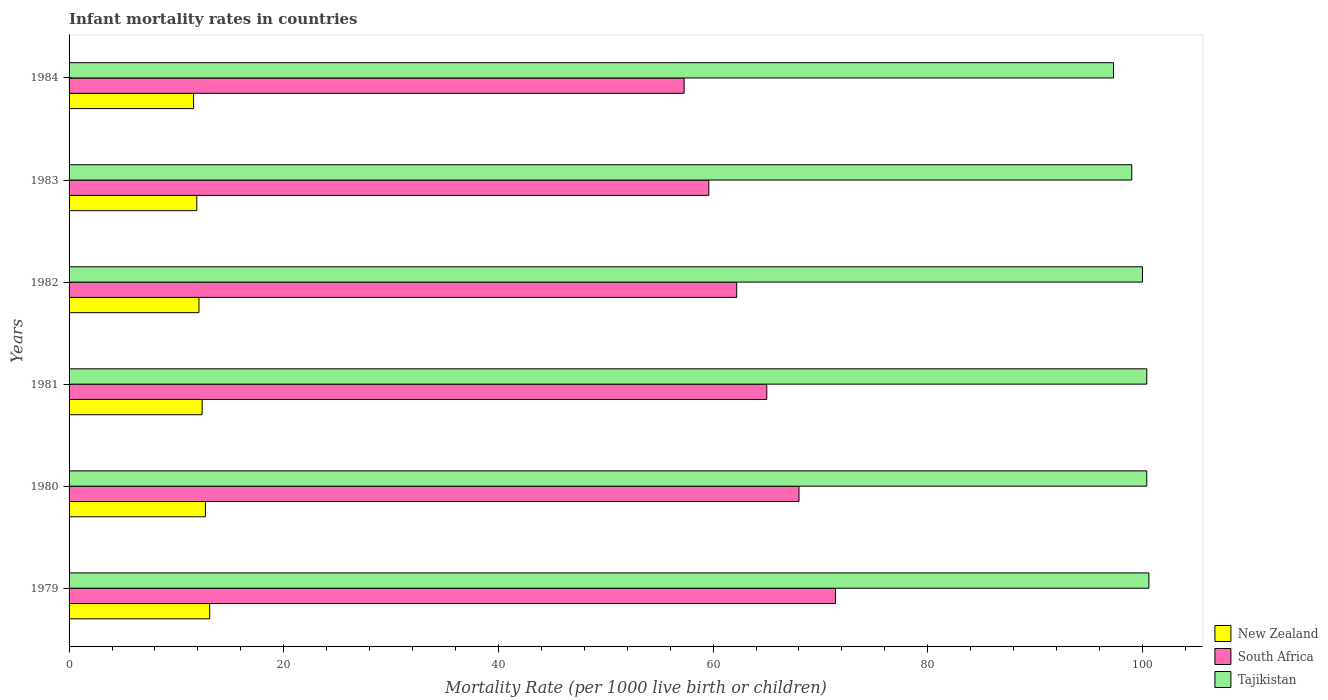How many groups of bars are there?
Your answer should be very brief. 6. How many bars are there on the 3rd tick from the bottom?
Ensure brevity in your answer.  3. What is the label of the 6th group of bars from the top?
Your answer should be compact. 1979. In how many cases, is the number of bars for a given year not equal to the number of legend labels?
Provide a short and direct response. 0. What is the infant mortality rate in Tajikistan in 1982?
Your answer should be compact. 100. Across all years, what is the minimum infant mortality rate in South Africa?
Offer a terse response. 57.3. In which year was the infant mortality rate in South Africa maximum?
Your answer should be very brief. 1979. What is the total infant mortality rate in South Africa in the graph?
Offer a very short reply. 383.5. What is the difference between the infant mortality rate in New Zealand in 1982 and that in 1984?
Give a very brief answer. 0.5. What is the average infant mortality rate in New Zealand per year?
Your answer should be compact. 12.3. In the year 1983, what is the difference between the infant mortality rate in Tajikistan and infant mortality rate in South Africa?
Provide a succinct answer. 39.4. In how many years, is the infant mortality rate in Tajikistan greater than 84 ?
Provide a short and direct response. 6. What is the ratio of the infant mortality rate in Tajikistan in 1979 to that in 1983?
Your answer should be compact. 1.02. What is the difference between the highest and the second highest infant mortality rate in South Africa?
Your answer should be very brief. 3.4. What is the difference between the highest and the lowest infant mortality rate in South Africa?
Keep it short and to the point. 14.1. What does the 2nd bar from the top in 1981 represents?
Give a very brief answer. South Africa. What does the 2nd bar from the bottom in 1983 represents?
Offer a very short reply. South Africa. Is it the case that in every year, the sum of the infant mortality rate in Tajikistan and infant mortality rate in South Africa is greater than the infant mortality rate in New Zealand?
Keep it short and to the point. Yes. How many bars are there?
Keep it short and to the point. 18. Are the values on the major ticks of X-axis written in scientific E-notation?
Your response must be concise. No. How are the legend labels stacked?
Offer a terse response. Vertical. What is the title of the graph?
Keep it short and to the point. Infant mortality rates in countries. What is the label or title of the X-axis?
Give a very brief answer. Mortality Rate (per 1000 live birth or children). What is the label or title of the Y-axis?
Your answer should be very brief. Years. What is the Mortality Rate (per 1000 live birth or children) of South Africa in 1979?
Offer a terse response. 71.4. What is the Mortality Rate (per 1000 live birth or children) of Tajikistan in 1979?
Offer a terse response. 100.6. What is the Mortality Rate (per 1000 live birth or children) of New Zealand in 1980?
Ensure brevity in your answer.  12.7. What is the Mortality Rate (per 1000 live birth or children) in South Africa in 1980?
Keep it short and to the point. 68. What is the Mortality Rate (per 1000 live birth or children) in Tajikistan in 1980?
Ensure brevity in your answer.  100.4. What is the Mortality Rate (per 1000 live birth or children) of New Zealand in 1981?
Give a very brief answer. 12.4. What is the Mortality Rate (per 1000 live birth or children) in Tajikistan in 1981?
Keep it short and to the point. 100.4. What is the Mortality Rate (per 1000 live birth or children) of New Zealand in 1982?
Keep it short and to the point. 12.1. What is the Mortality Rate (per 1000 live birth or children) of South Africa in 1982?
Make the answer very short. 62.2. What is the Mortality Rate (per 1000 live birth or children) in Tajikistan in 1982?
Offer a very short reply. 100. What is the Mortality Rate (per 1000 live birth or children) in New Zealand in 1983?
Your response must be concise. 11.9. What is the Mortality Rate (per 1000 live birth or children) in South Africa in 1983?
Make the answer very short. 59.6. What is the Mortality Rate (per 1000 live birth or children) of Tajikistan in 1983?
Your answer should be very brief. 99. What is the Mortality Rate (per 1000 live birth or children) in New Zealand in 1984?
Your answer should be very brief. 11.6. What is the Mortality Rate (per 1000 live birth or children) in South Africa in 1984?
Give a very brief answer. 57.3. What is the Mortality Rate (per 1000 live birth or children) in Tajikistan in 1984?
Provide a short and direct response. 97.3. Across all years, what is the maximum Mortality Rate (per 1000 live birth or children) in South Africa?
Offer a very short reply. 71.4. Across all years, what is the maximum Mortality Rate (per 1000 live birth or children) of Tajikistan?
Offer a very short reply. 100.6. Across all years, what is the minimum Mortality Rate (per 1000 live birth or children) in South Africa?
Provide a succinct answer. 57.3. Across all years, what is the minimum Mortality Rate (per 1000 live birth or children) of Tajikistan?
Keep it short and to the point. 97.3. What is the total Mortality Rate (per 1000 live birth or children) in New Zealand in the graph?
Offer a terse response. 73.8. What is the total Mortality Rate (per 1000 live birth or children) of South Africa in the graph?
Your answer should be compact. 383.5. What is the total Mortality Rate (per 1000 live birth or children) of Tajikistan in the graph?
Offer a terse response. 597.7. What is the difference between the Mortality Rate (per 1000 live birth or children) of New Zealand in 1979 and that in 1980?
Your response must be concise. 0.4. What is the difference between the Mortality Rate (per 1000 live birth or children) in New Zealand in 1979 and that in 1981?
Offer a very short reply. 0.7. What is the difference between the Mortality Rate (per 1000 live birth or children) in Tajikistan in 1979 and that in 1981?
Make the answer very short. 0.2. What is the difference between the Mortality Rate (per 1000 live birth or children) in South Africa in 1979 and that in 1982?
Keep it short and to the point. 9.2. What is the difference between the Mortality Rate (per 1000 live birth or children) in Tajikistan in 1979 and that in 1982?
Make the answer very short. 0.6. What is the difference between the Mortality Rate (per 1000 live birth or children) in New Zealand in 1979 and that in 1983?
Keep it short and to the point. 1.2. What is the difference between the Mortality Rate (per 1000 live birth or children) in Tajikistan in 1979 and that in 1983?
Offer a very short reply. 1.6. What is the difference between the Mortality Rate (per 1000 live birth or children) of New Zealand in 1979 and that in 1984?
Provide a succinct answer. 1.5. What is the difference between the Mortality Rate (per 1000 live birth or children) in New Zealand in 1980 and that in 1982?
Your response must be concise. 0.6. What is the difference between the Mortality Rate (per 1000 live birth or children) in Tajikistan in 1980 and that in 1982?
Provide a succinct answer. 0.4. What is the difference between the Mortality Rate (per 1000 live birth or children) of South Africa in 1980 and that in 1983?
Your answer should be very brief. 8.4. What is the difference between the Mortality Rate (per 1000 live birth or children) of New Zealand in 1980 and that in 1984?
Make the answer very short. 1.1. What is the difference between the Mortality Rate (per 1000 live birth or children) in South Africa in 1980 and that in 1984?
Your answer should be compact. 10.7. What is the difference between the Mortality Rate (per 1000 live birth or children) of Tajikistan in 1980 and that in 1984?
Your response must be concise. 3.1. What is the difference between the Mortality Rate (per 1000 live birth or children) of Tajikistan in 1981 and that in 1982?
Provide a short and direct response. 0.4. What is the difference between the Mortality Rate (per 1000 live birth or children) in New Zealand in 1981 and that in 1983?
Offer a very short reply. 0.5. What is the difference between the Mortality Rate (per 1000 live birth or children) of New Zealand in 1981 and that in 1984?
Keep it short and to the point. 0.8. What is the difference between the Mortality Rate (per 1000 live birth or children) in South Africa in 1981 and that in 1984?
Give a very brief answer. 7.7. What is the difference between the Mortality Rate (per 1000 live birth or children) of Tajikistan in 1981 and that in 1984?
Provide a short and direct response. 3.1. What is the difference between the Mortality Rate (per 1000 live birth or children) of Tajikistan in 1982 and that in 1983?
Your response must be concise. 1. What is the difference between the Mortality Rate (per 1000 live birth or children) of New Zealand in 1983 and that in 1984?
Offer a terse response. 0.3. What is the difference between the Mortality Rate (per 1000 live birth or children) of Tajikistan in 1983 and that in 1984?
Provide a short and direct response. 1.7. What is the difference between the Mortality Rate (per 1000 live birth or children) in New Zealand in 1979 and the Mortality Rate (per 1000 live birth or children) in South Africa in 1980?
Offer a terse response. -54.9. What is the difference between the Mortality Rate (per 1000 live birth or children) in New Zealand in 1979 and the Mortality Rate (per 1000 live birth or children) in Tajikistan in 1980?
Your response must be concise. -87.3. What is the difference between the Mortality Rate (per 1000 live birth or children) in New Zealand in 1979 and the Mortality Rate (per 1000 live birth or children) in South Africa in 1981?
Make the answer very short. -51.9. What is the difference between the Mortality Rate (per 1000 live birth or children) of New Zealand in 1979 and the Mortality Rate (per 1000 live birth or children) of Tajikistan in 1981?
Give a very brief answer. -87.3. What is the difference between the Mortality Rate (per 1000 live birth or children) of South Africa in 1979 and the Mortality Rate (per 1000 live birth or children) of Tajikistan in 1981?
Your answer should be very brief. -29. What is the difference between the Mortality Rate (per 1000 live birth or children) in New Zealand in 1979 and the Mortality Rate (per 1000 live birth or children) in South Africa in 1982?
Ensure brevity in your answer.  -49.1. What is the difference between the Mortality Rate (per 1000 live birth or children) of New Zealand in 1979 and the Mortality Rate (per 1000 live birth or children) of Tajikistan in 1982?
Provide a short and direct response. -86.9. What is the difference between the Mortality Rate (per 1000 live birth or children) of South Africa in 1979 and the Mortality Rate (per 1000 live birth or children) of Tajikistan in 1982?
Ensure brevity in your answer.  -28.6. What is the difference between the Mortality Rate (per 1000 live birth or children) of New Zealand in 1979 and the Mortality Rate (per 1000 live birth or children) of South Africa in 1983?
Provide a short and direct response. -46.5. What is the difference between the Mortality Rate (per 1000 live birth or children) in New Zealand in 1979 and the Mortality Rate (per 1000 live birth or children) in Tajikistan in 1983?
Offer a terse response. -85.9. What is the difference between the Mortality Rate (per 1000 live birth or children) in South Africa in 1979 and the Mortality Rate (per 1000 live birth or children) in Tajikistan in 1983?
Your answer should be very brief. -27.6. What is the difference between the Mortality Rate (per 1000 live birth or children) of New Zealand in 1979 and the Mortality Rate (per 1000 live birth or children) of South Africa in 1984?
Give a very brief answer. -44.2. What is the difference between the Mortality Rate (per 1000 live birth or children) of New Zealand in 1979 and the Mortality Rate (per 1000 live birth or children) of Tajikistan in 1984?
Offer a very short reply. -84.2. What is the difference between the Mortality Rate (per 1000 live birth or children) of South Africa in 1979 and the Mortality Rate (per 1000 live birth or children) of Tajikistan in 1984?
Offer a terse response. -25.9. What is the difference between the Mortality Rate (per 1000 live birth or children) in New Zealand in 1980 and the Mortality Rate (per 1000 live birth or children) in South Africa in 1981?
Offer a terse response. -52.3. What is the difference between the Mortality Rate (per 1000 live birth or children) of New Zealand in 1980 and the Mortality Rate (per 1000 live birth or children) of Tajikistan in 1981?
Make the answer very short. -87.7. What is the difference between the Mortality Rate (per 1000 live birth or children) in South Africa in 1980 and the Mortality Rate (per 1000 live birth or children) in Tajikistan in 1981?
Keep it short and to the point. -32.4. What is the difference between the Mortality Rate (per 1000 live birth or children) of New Zealand in 1980 and the Mortality Rate (per 1000 live birth or children) of South Africa in 1982?
Keep it short and to the point. -49.5. What is the difference between the Mortality Rate (per 1000 live birth or children) of New Zealand in 1980 and the Mortality Rate (per 1000 live birth or children) of Tajikistan in 1982?
Give a very brief answer. -87.3. What is the difference between the Mortality Rate (per 1000 live birth or children) of South Africa in 1980 and the Mortality Rate (per 1000 live birth or children) of Tajikistan in 1982?
Your answer should be very brief. -32. What is the difference between the Mortality Rate (per 1000 live birth or children) of New Zealand in 1980 and the Mortality Rate (per 1000 live birth or children) of South Africa in 1983?
Give a very brief answer. -46.9. What is the difference between the Mortality Rate (per 1000 live birth or children) of New Zealand in 1980 and the Mortality Rate (per 1000 live birth or children) of Tajikistan in 1983?
Give a very brief answer. -86.3. What is the difference between the Mortality Rate (per 1000 live birth or children) of South Africa in 1980 and the Mortality Rate (per 1000 live birth or children) of Tajikistan in 1983?
Keep it short and to the point. -31. What is the difference between the Mortality Rate (per 1000 live birth or children) in New Zealand in 1980 and the Mortality Rate (per 1000 live birth or children) in South Africa in 1984?
Your response must be concise. -44.6. What is the difference between the Mortality Rate (per 1000 live birth or children) in New Zealand in 1980 and the Mortality Rate (per 1000 live birth or children) in Tajikistan in 1984?
Give a very brief answer. -84.6. What is the difference between the Mortality Rate (per 1000 live birth or children) in South Africa in 1980 and the Mortality Rate (per 1000 live birth or children) in Tajikistan in 1984?
Give a very brief answer. -29.3. What is the difference between the Mortality Rate (per 1000 live birth or children) in New Zealand in 1981 and the Mortality Rate (per 1000 live birth or children) in South Africa in 1982?
Give a very brief answer. -49.8. What is the difference between the Mortality Rate (per 1000 live birth or children) of New Zealand in 1981 and the Mortality Rate (per 1000 live birth or children) of Tajikistan in 1982?
Provide a short and direct response. -87.6. What is the difference between the Mortality Rate (per 1000 live birth or children) of South Africa in 1981 and the Mortality Rate (per 1000 live birth or children) of Tajikistan in 1982?
Provide a succinct answer. -35. What is the difference between the Mortality Rate (per 1000 live birth or children) in New Zealand in 1981 and the Mortality Rate (per 1000 live birth or children) in South Africa in 1983?
Offer a very short reply. -47.2. What is the difference between the Mortality Rate (per 1000 live birth or children) of New Zealand in 1981 and the Mortality Rate (per 1000 live birth or children) of Tajikistan in 1983?
Offer a very short reply. -86.6. What is the difference between the Mortality Rate (per 1000 live birth or children) in South Africa in 1981 and the Mortality Rate (per 1000 live birth or children) in Tajikistan in 1983?
Offer a very short reply. -34. What is the difference between the Mortality Rate (per 1000 live birth or children) of New Zealand in 1981 and the Mortality Rate (per 1000 live birth or children) of South Africa in 1984?
Give a very brief answer. -44.9. What is the difference between the Mortality Rate (per 1000 live birth or children) of New Zealand in 1981 and the Mortality Rate (per 1000 live birth or children) of Tajikistan in 1984?
Offer a terse response. -84.9. What is the difference between the Mortality Rate (per 1000 live birth or children) of South Africa in 1981 and the Mortality Rate (per 1000 live birth or children) of Tajikistan in 1984?
Make the answer very short. -32.3. What is the difference between the Mortality Rate (per 1000 live birth or children) in New Zealand in 1982 and the Mortality Rate (per 1000 live birth or children) in South Africa in 1983?
Offer a very short reply. -47.5. What is the difference between the Mortality Rate (per 1000 live birth or children) of New Zealand in 1982 and the Mortality Rate (per 1000 live birth or children) of Tajikistan in 1983?
Offer a very short reply. -86.9. What is the difference between the Mortality Rate (per 1000 live birth or children) in South Africa in 1982 and the Mortality Rate (per 1000 live birth or children) in Tajikistan in 1983?
Provide a short and direct response. -36.8. What is the difference between the Mortality Rate (per 1000 live birth or children) in New Zealand in 1982 and the Mortality Rate (per 1000 live birth or children) in South Africa in 1984?
Offer a terse response. -45.2. What is the difference between the Mortality Rate (per 1000 live birth or children) in New Zealand in 1982 and the Mortality Rate (per 1000 live birth or children) in Tajikistan in 1984?
Ensure brevity in your answer.  -85.2. What is the difference between the Mortality Rate (per 1000 live birth or children) in South Africa in 1982 and the Mortality Rate (per 1000 live birth or children) in Tajikistan in 1984?
Ensure brevity in your answer.  -35.1. What is the difference between the Mortality Rate (per 1000 live birth or children) of New Zealand in 1983 and the Mortality Rate (per 1000 live birth or children) of South Africa in 1984?
Keep it short and to the point. -45.4. What is the difference between the Mortality Rate (per 1000 live birth or children) in New Zealand in 1983 and the Mortality Rate (per 1000 live birth or children) in Tajikistan in 1984?
Offer a very short reply. -85.4. What is the difference between the Mortality Rate (per 1000 live birth or children) of South Africa in 1983 and the Mortality Rate (per 1000 live birth or children) of Tajikistan in 1984?
Keep it short and to the point. -37.7. What is the average Mortality Rate (per 1000 live birth or children) in South Africa per year?
Provide a succinct answer. 63.92. What is the average Mortality Rate (per 1000 live birth or children) in Tajikistan per year?
Give a very brief answer. 99.62. In the year 1979, what is the difference between the Mortality Rate (per 1000 live birth or children) in New Zealand and Mortality Rate (per 1000 live birth or children) in South Africa?
Your answer should be very brief. -58.3. In the year 1979, what is the difference between the Mortality Rate (per 1000 live birth or children) of New Zealand and Mortality Rate (per 1000 live birth or children) of Tajikistan?
Your response must be concise. -87.5. In the year 1979, what is the difference between the Mortality Rate (per 1000 live birth or children) of South Africa and Mortality Rate (per 1000 live birth or children) of Tajikistan?
Your answer should be very brief. -29.2. In the year 1980, what is the difference between the Mortality Rate (per 1000 live birth or children) of New Zealand and Mortality Rate (per 1000 live birth or children) of South Africa?
Make the answer very short. -55.3. In the year 1980, what is the difference between the Mortality Rate (per 1000 live birth or children) in New Zealand and Mortality Rate (per 1000 live birth or children) in Tajikistan?
Make the answer very short. -87.7. In the year 1980, what is the difference between the Mortality Rate (per 1000 live birth or children) in South Africa and Mortality Rate (per 1000 live birth or children) in Tajikistan?
Your answer should be very brief. -32.4. In the year 1981, what is the difference between the Mortality Rate (per 1000 live birth or children) of New Zealand and Mortality Rate (per 1000 live birth or children) of South Africa?
Ensure brevity in your answer.  -52.6. In the year 1981, what is the difference between the Mortality Rate (per 1000 live birth or children) in New Zealand and Mortality Rate (per 1000 live birth or children) in Tajikistan?
Ensure brevity in your answer.  -88. In the year 1981, what is the difference between the Mortality Rate (per 1000 live birth or children) in South Africa and Mortality Rate (per 1000 live birth or children) in Tajikistan?
Your answer should be very brief. -35.4. In the year 1982, what is the difference between the Mortality Rate (per 1000 live birth or children) of New Zealand and Mortality Rate (per 1000 live birth or children) of South Africa?
Offer a terse response. -50.1. In the year 1982, what is the difference between the Mortality Rate (per 1000 live birth or children) in New Zealand and Mortality Rate (per 1000 live birth or children) in Tajikistan?
Keep it short and to the point. -87.9. In the year 1982, what is the difference between the Mortality Rate (per 1000 live birth or children) in South Africa and Mortality Rate (per 1000 live birth or children) in Tajikistan?
Keep it short and to the point. -37.8. In the year 1983, what is the difference between the Mortality Rate (per 1000 live birth or children) in New Zealand and Mortality Rate (per 1000 live birth or children) in South Africa?
Your answer should be very brief. -47.7. In the year 1983, what is the difference between the Mortality Rate (per 1000 live birth or children) of New Zealand and Mortality Rate (per 1000 live birth or children) of Tajikistan?
Provide a short and direct response. -87.1. In the year 1983, what is the difference between the Mortality Rate (per 1000 live birth or children) of South Africa and Mortality Rate (per 1000 live birth or children) of Tajikistan?
Give a very brief answer. -39.4. In the year 1984, what is the difference between the Mortality Rate (per 1000 live birth or children) in New Zealand and Mortality Rate (per 1000 live birth or children) in South Africa?
Offer a terse response. -45.7. In the year 1984, what is the difference between the Mortality Rate (per 1000 live birth or children) of New Zealand and Mortality Rate (per 1000 live birth or children) of Tajikistan?
Provide a succinct answer. -85.7. What is the ratio of the Mortality Rate (per 1000 live birth or children) of New Zealand in 1979 to that in 1980?
Your response must be concise. 1.03. What is the ratio of the Mortality Rate (per 1000 live birth or children) in South Africa in 1979 to that in 1980?
Your answer should be compact. 1.05. What is the ratio of the Mortality Rate (per 1000 live birth or children) in New Zealand in 1979 to that in 1981?
Ensure brevity in your answer.  1.06. What is the ratio of the Mortality Rate (per 1000 live birth or children) of South Africa in 1979 to that in 1981?
Make the answer very short. 1.1. What is the ratio of the Mortality Rate (per 1000 live birth or children) of New Zealand in 1979 to that in 1982?
Provide a succinct answer. 1.08. What is the ratio of the Mortality Rate (per 1000 live birth or children) of South Africa in 1979 to that in 1982?
Offer a very short reply. 1.15. What is the ratio of the Mortality Rate (per 1000 live birth or children) in Tajikistan in 1979 to that in 1982?
Offer a terse response. 1.01. What is the ratio of the Mortality Rate (per 1000 live birth or children) of New Zealand in 1979 to that in 1983?
Offer a terse response. 1.1. What is the ratio of the Mortality Rate (per 1000 live birth or children) in South Africa in 1979 to that in 1983?
Offer a terse response. 1.2. What is the ratio of the Mortality Rate (per 1000 live birth or children) in Tajikistan in 1979 to that in 1983?
Offer a terse response. 1.02. What is the ratio of the Mortality Rate (per 1000 live birth or children) in New Zealand in 1979 to that in 1984?
Provide a short and direct response. 1.13. What is the ratio of the Mortality Rate (per 1000 live birth or children) in South Africa in 1979 to that in 1984?
Provide a short and direct response. 1.25. What is the ratio of the Mortality Rate (per 1000 live birth or children) of Tajikistan in 1979 to that in 1984?
Your response must be concise. 1.03. What is the ratio of the Mortality Rate (per 1000 live birth or children) in New Zealand in 1980 to that in 1981?
Your answer should be compact. 1.02. What is the ratio of the Mortality Rate (per 1000 live birth or children) in South Africa in 1980 to that in 1981?
Offer a very short reply. 1.05. What is the ratio of the Mortality Rate (per 1000 live birth or children) in Tajikistan in 1980 to that in 1981?
Make the answer very short. 1. What is the ratio of the Mortality Rate (per 1000 live birth or children) in New Zealand in 1980 to that in 1982?
Keep it short and to the point. 1.05. What is the ratio of the Mortality Rate (per 1000 live birth or children) in South Africa in 1980 to that in 1982?
Your answer should be very brief. 1.09. What is the ratio of the Mortality Rate (per 1000 live birth or children) in Tajikistan in 1980 to that in 1982?
Ensure brevity in your answer.  1. What is the ratio of the Mortality Rate (per 1000 live birth or children) in New Zealand in 1980 to that in 1983?
Provide a short and direct response. 1.07. What is the ratio of the Mortality Rate (per 1000 live birth or children) in South Africa in 1980 to that in 1983?
Offer a very short reply. 1.14. What is the ratio of the Mortality Rate (per 1000 live birth or children) of Tajikistan in 1980 to that in 1983?
Your answer should be very brief. 1.01. What is the ratio of the Mortality Rate (per 1000 live birth or children) of New Zealand in 1980 to that in 1984?
Offer a terse response. 1.09. What is the ratio of the Mortality Rate (per 1000 live birth or children) in South Africa in 1980 to that in 1984?
Give a very brief answer. 1.19. What is the ratio of the Mortality Rate (per 1000 live birth or children) of Tajikistan in 1980 to that in 1984?
Offer a very short reply. 1.03. What is the ratio of the Mortality Rate (per 1000 live birth or children) of New Zealand in 1981 to that in 1982?
Your response must be concise. 1.02. What is the ratio of the Mortality Rate (per 1000 live birth or children) of South Africa in 1981 to that in 1982?
Your response must be concise. 1.04. What is the ratio of the Mortality Rate (per 1000 live birth or children) in Tajikistan in 1981 to that in 1982?
Make the answer very short. 1. What is the ratio of the Mortality Rate (per 1000 live birth or children) in New Zealand in 1981 to that in 1983?
Your answer should be compact. 1.04. What is the ratio of the Mortality Rate (per 1000 live birth or children) of South Africa in 1981 to that in 1983?
Provide a succinct answer. 1.09. What is the ratio of the Mortality Rate (per 1000 live birth or children) in Tajikistan in 1981 to that in 1983?
Offer a very short reply. 1.01. What is the ratio of the Mortality Rate (per 1000 live birth or children) of New Zealand in 1981 to that in 1984?
Ensure brevity in your answer.  1.07. What is the ratio of the Mortality Rate (per 1000 live birth or children) of South Africa in 1981 to that in 1984?
Your answer should be very brief. 1.13. What is the ratio of the Mortality Rate (per 1000 live birth or children) in Tajikistan in 1981 to that in 1984?
Keep it short and to the point. 1.03. What is the ratio of the Mortality Rate (per 1000 live birth or children) in New Zealand in 1982 to that in 1983?
Provide a succinct answer. 1.02. What is the ratio of the Mortality Rate (per 1000 live birth or children) of South Africa in 1982 to that in 1983?
Offer a very short reply. 1.04. What is the ratio of the Mortality Rate (per 1000 live birth or children) in New Zealand in 1982 to that in 1984?
Your answer should be compact. 1.04. What is the ratio of the Mortality Rate (per 1000 live birth or children) of South Africa in 1982 to that in 1984?
Offer a very short reply. 1.09. What is the ratio of the Mortality Rate (per 1000 live birth or children) of Tajikistan in 1982 to that in 1984?
Make the answer very short. 1.03. What is the ratio of the Mortality Rate (per 1000 live birth or children) in New Zealand in 1983 to that in 1984?
Provide a short and direct response. 1.03. What is the ratio of the Mortality Rate (per 1000 live birth or children) in South Africa in 1983 to that in 1984?
Your answer should be very brief. 1.04. What is the ratio of the Mortality Rate (per 1000 live birth or children) of Tajikistan in 1983 to that in 1984?
Ensure brevity in your answer.  1.02. What is the difference between the highest and the second highest Mortality Rate (per 1000 live birth or children) in New Zealand?
Offer a terse response. 0.4. What is the difference between the highest and the lowest Mortality Rate (per 1000 live birth or children) in South Africa?
Provide a succinct answer. 14.1. 